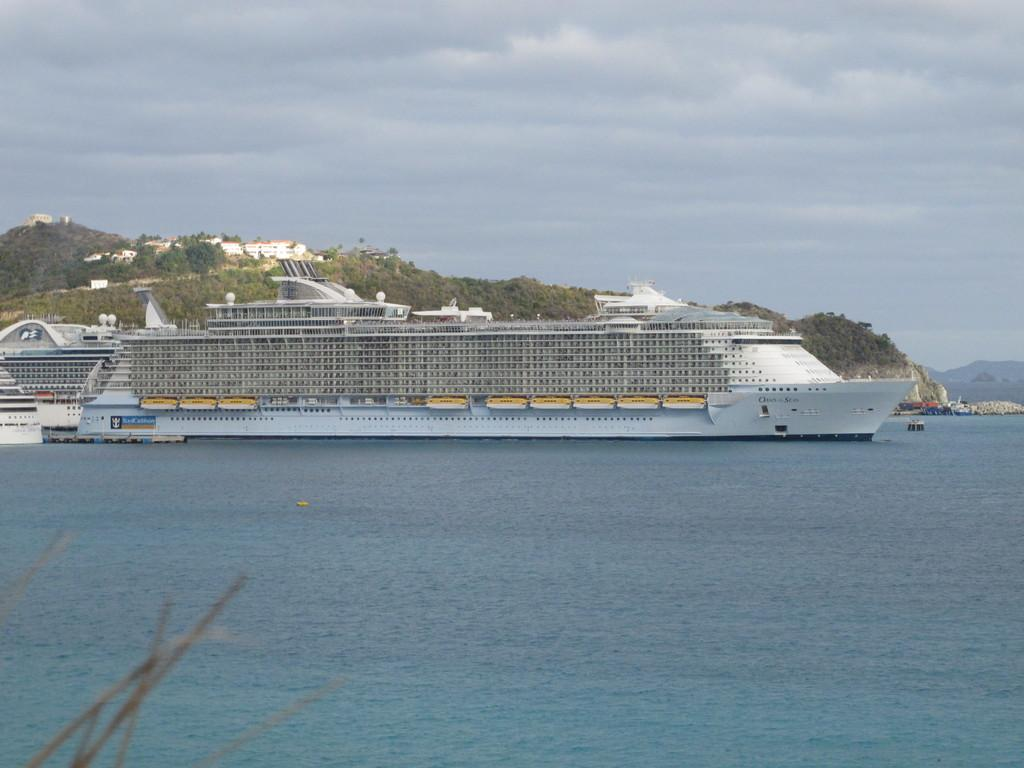What is the main subject of the image? There is a ship in the image. Where is the ship located? The ship is on the water. What can be seen in the background of the image? There are trees and buildings in the background of the image. What is the color of the trees? The trees are green. What is visible in the sky in the image? The sky has a white and blue color. What type of government is depicted in the image? There is no depiction of a government in the image; it features a ship on the water with trees, buildings, and a sky in the background. Can you tell me how many zebras are swimming near the ship in the image? There are no zebras present in the image; it features a ship on the water with trees, buildings, and a sky in the background. 